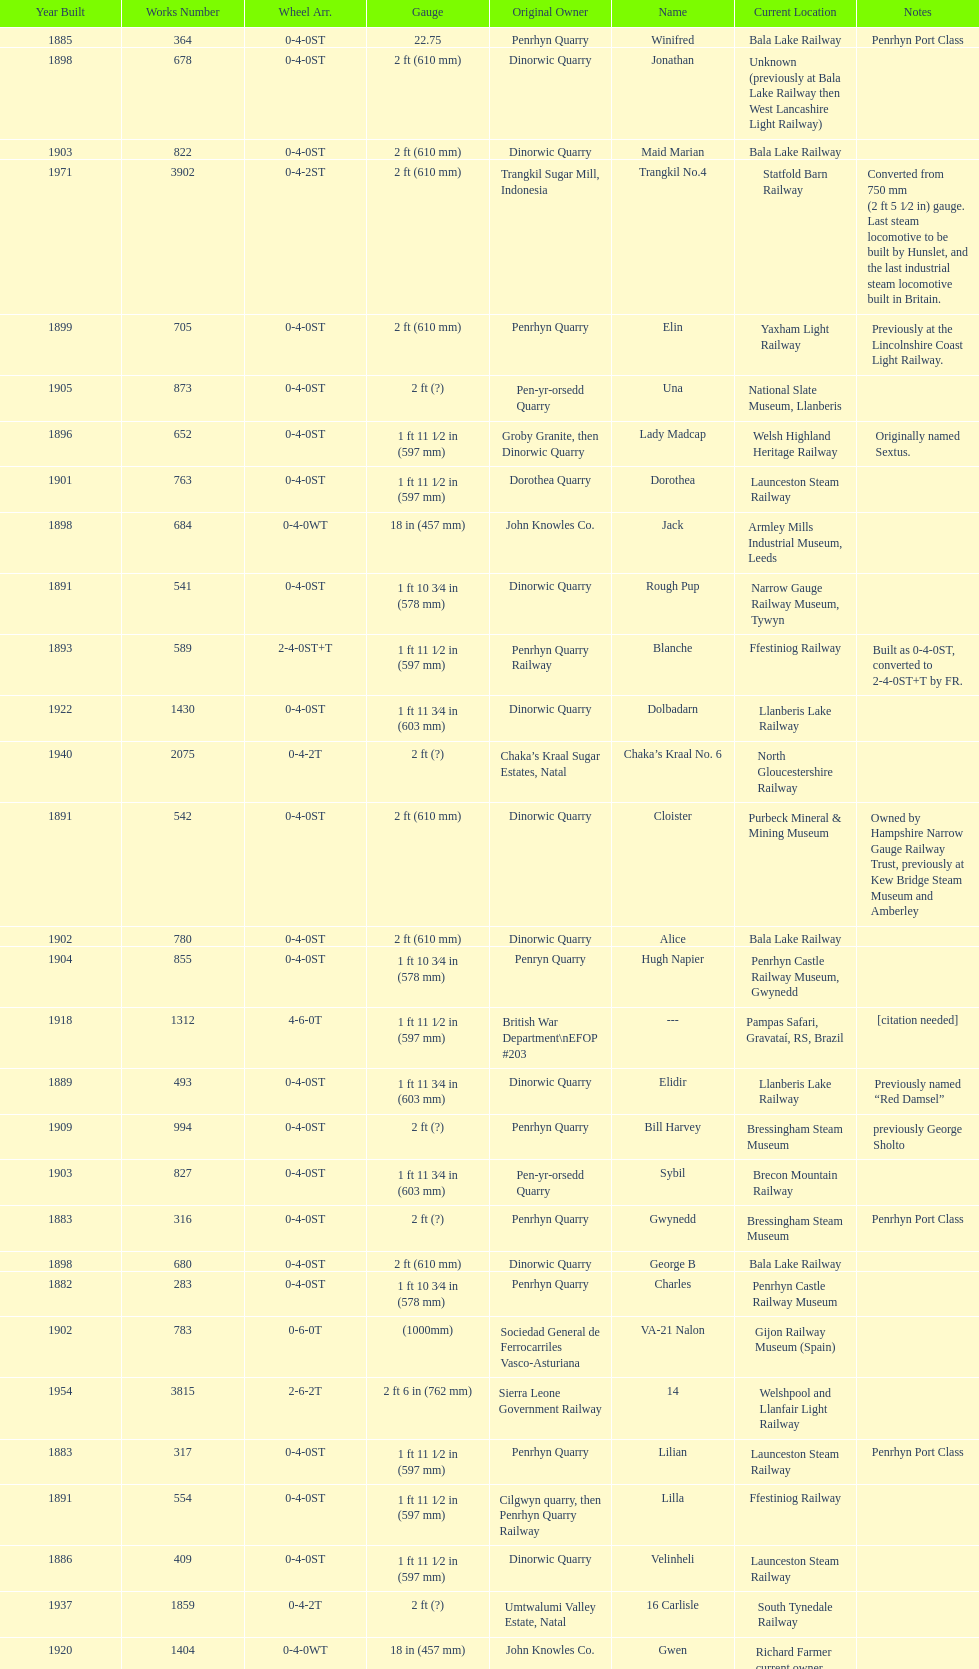Could you parse the entire table? {'header': ['Year Built', 'Works Number', 'Wheel Arr.', 'Gauge', 'Original Owner', 'Name', 'Current Location', 'Notes'], 'rows': [['1885', '364', '0-4-0ST', '22.75', 'Penrhyn Quarry', 'Winifred', 'Bala Lake Railway', 'Penrhyn Port Class'], ['1898', '678', '0-4-0ST', '2\xa0ft (610\xa0mm)', 'Dinorwic Quarry', 'Jonathan', 'Unknown (previously at Bala Lake Railway then West Lancashire Light Railway)', ''], ['1903', '822', '0-4-0ST', '2\xa0ft (610\xa0mm)', 'Dinorwic Quarry', 'Maid Marian', 'Bala Lake Railway', ''], ['1971', '3902', '0-4-2ST', '2\xa0ft (610\xa0mm)', 'Trangkil Sugar Mill, Indonesia', 'Trangkil No.4', 'Statfold Barn Railway', 'Converted from 750\xa0mm (2\xa0ft\xa05\xa01⁄2\xa0in) gauge. Last steam locomotive to be built by Hunslet, and the last industrial steam locomotive built in Britain.'], ['1899', '705', '0-4-0ST', '2\xa0ft (610\xa0mm)', 'Penrhyn Quarry', 'Elin', 'Yaxham Light Railway', 'Previously at the Lincolnshire Coast Light Railway.'], ['1905', '873', '0-4-0ST', '2\xa0ft (?)', 'Pen-yr-orsedd Quarry', 'Una', 'National Slate Museum, Llanberis', ''], ['1896', '652', '0-4-0ST', '1\xa0ft 11\xa01⁄2\xa0in (597\xa0mm)', 'Groby Granite, then Dinorwic Quarry', 'Lady Madcap', 'Welsh Highland Heritage Railway', 'Originally named Sextus.'], ['1901', '763', '0-4-0ST', '1\xa0ft 11\xa01⁄2\xa0in (597\xa0mm)', 'Dorothea Quarry', 'Dorothea', 'Launceston Steam Railway', ''], ['1898', '684', '0-4-0WT', '18\xa0in (457\xa0mm)', 'John Knowles Co.', 'Jack', 'Armley Mills Industrial Museum, Leeds', ''], ['1891', '541', '0-4-0ST', '1\xa0ft 10\xa03⁄4\xa0in (578\xa0mm)', 'Dinorwic Quarry', 'Rough Pup', 'Narrow Gauge Railway Museum, Tywyn', ''], ['1893', '589', '2-4-0ST+T', '1\xa0ft 11\xa01⁄2\xa0in (597\xa0mm)', 'Penrhyn Quarry Railway', 'Blanche', 'Ffestiniog Railway', 'Built as 0-4-0ST, converted to 2-4-0ST+T by FR.'], ['1922', '1430', '0-4-0ST', '1\xa0ft 11\xa03⁄4\xa0in (603\xa0mm)', 'Dinorwic Quarry', 'Dolbadarn', 'Llanberis Lake Railway', ''], ['1940', '2075', '0-4-2T', '2\xa0ft (?)', 'Chaka’s Kraal Sugar Estates, Natal', 'Chaka’s Kraal No. 6', 'North Gloucestershire Railway', ''], ['1891', '542', '0-4-0ST', '2\xa0ft (610\xa0mm)', 'Dinorwic Quarry', 'Cloister', 'Purbeck Mineral & Mining Museum', 'Owned by Hampshire Narrow Gauge Railway Trust, previously at Kew Bridge Steam Museum and Amberley'], ['1902', '780', '0-4-0ST', '2\xa0ft (610\xa0mm)', 'Dinorwic Quarry', 'Alice', 'Bala Lake Railway', ''], ['1904', '855', '0-4-0ST', '1\xa0ft 10\xa03⁄4\xa0in (578\xa0mm)', 'Penryn Quarry', 'Hugh Napier', 'Penrhyn Castle Railway Museum, Gwynedd', ''], ['1918', '1312', '4-6-0T', '1\xa0ft\xa011\xa01⁄2\xa0in (597\xa0mm)', 'British War Department\\nEFOP #203', '---', 'Pampas Safari, Gravataí, RS, Brazil', '[citation needed]'], ['1889', '493', '0-4-0ST', '1\xa0ft 11\xa03⁄4\xa0in (603\xa0mm)', 'Dinorwic Quarry', 'Elidir', 'Llanberis Lake Railway', 'Previously named “Red Damsel”'], ['1909', '994', '0-4-0ST', '2\xa0ft (?)', 'Penrhyn Quarry', 'Bill Harvey', 'Bressingham Steam Museum', 'previously George Sholto'], ['1903', '827', '0-4-0ST', '1\xa0ft 11\xa03⁄4\xa0in (603\xa0mm)', 'Pen-yr-orsedd Quarry', 'Sybil', 'Brecon Mountain Railway', ''], ['1883', '316', '0-4-0ST', '2\xa0ft (?)', 'Penrhyn Quarry', 'Gwynedd', 'Bressingham Steam Museum', 'Penrhyn Port Class'], ['1898', '680', '0-4-0ST', '2\xa0ft (610\xa0mm)', 'Dinorwic Quarry', 'George B', 'Bala Lake Railway', ''], ['1882', '283', '0-4-0ST', '1\xa0ft 10\xa03⁄4\xa0in (578\xa0mm)', 'Penrhyn Quarry', 'Charles', 'Penrhyn Castle Railway Museum', ''], ['1902', '783', '0-6-0T', '(1000mm)', 'Sociedad General de Ferrocarriles Vasco-Asturiana', 'VA-21 Nalon', 'Gijon Railway Museum (Spain)', ''], ['1954', '3815', '2-6-2T', '2\xa0ft 6\xa0in (762\xa0mm)', 'Sierra Leone Government Railway', '14', 'Welshpool and Llanfair Light Railway', ''], ['1883', '317', '0-4-0ST', '1\xa0ft 11\xa01⁄2\xa0in (597\xa0mm)', 'Penrhyn Quarry', 'Lilian', 'Launceston Steam Railway', 'Penrhyn Port Class'], ['1891', '554', '0-4-0ST', '1\xa0ft 11\xa01⁄2\xa0in (597\xa0mm)', 'Cilgwyn quarry, then Penrhyn Quarry Railway', 'Lilla', 'Ffestiniog Railway', ''], ['1886', '409', '0-4-0ST', '1\xa0ft 11\xa01⁄2\xa0in (597\xa0mm)', 'Dinorwic Quarry', 'Velinheli', 'Launceston Steam Railway', ''], ['1937', '1859', '0-4-2T', '2\xa0ft (?)', 'Umtwalumi Valley Estate, Natal', '16 Carlisle', 'South Tynedale Railway', ''], ['1920', '1404', '0-4-0WT', '18\xa0in (457\xa0mm)', 'John Knowles Co.', 'Gwen', 'Richard Farmer current owner, Northridge, California, USA', ''], ['1906', '920', '0-4-0ST', '2\xa0ft (?)', 'Penrhyn Quarry', 'Pamela', 'Old Kiln Light Railway', ''], ['1922', '1429', '0-4-0ST', '2\xa0ft (610\xa0mm)', 'Dinorwic', 'Lady Joan', 'Bredgar and Wormshill Light Railway', ''], ['1899', '707', '0-4-0ST', '1\xa0ft 11\xa01⁄2\xa0in (597\xa0mm)', 'Pen-yr-orsedd Quarry', 'Britomart', 'Ffestiniog Railway', ''], ['1898', '679', '0-4-0ST', '1\xa0ft 11\xa01⁄2\xa0in (597\xa0mm)', 'Dinorwic Quarry', 'Covercoat', 'Launceston Steam Railway', ''], ['1895', '638', '0-4-0ST', '2\xa0ft (610\xa0mm)', 'Dinorwic', 'Jerry M', 'Hollycombe Steam Collection', ''], ['1890', '518', '2-2-0T', '(1000mm)', 'S.V.T. 8', 'Tortosa-La Cava1', 'Tortosa (catalonia, Spain)', ''], ['1903', '823', '0-4-0ST', '2\xa0ft (?)', 'Dinorwic Quarry', 'Irish Mail', 'West Lancashire Light Railway', ''], ['1906', '901', '2-6-2T', '1\xa0ft 11\xa01⁄2\xa0in (597\xa0mm)', 'North Wales Narrow Gauge Railways', 'Russell', 'Welsh Highland Heritage Railway', ''], ['1893', '590', '2-4-0ST+T', '1\xa0ft 11\xa01⁄2\xa0in (597\xa0mm)', 'Penrhyn Quarry Railway', 'Linda', 'Ffestiniog Railway', 'Built as 0-4-0ST, converted to 2-4-0ST+T by FR.'], ['1902', '779', '0-4-0ST', '2\xa0ft (610\xa0mm)', 'Dinorwic Quarry', 'Holy War', 'Bala Lake Railway', ''], ['1894', '605', '0-4-0ST', '1\xa0ft 11\xa03⁄4\xa0in (603\xa0mm)', 'Penrhyn Quarry', 'Margaret', 'Vale of Rheidol Railway', 'Under restoration.[citation needed]'], ['1918\\nor\\n1921?', '1313', '0-6-2T', '3\xa0ft\xa03\xa03⁄8\xa0in (1,000\xa0mm)', 'British War Department\\nUsina Leão Utinga #1\\nUsina Laginha #1', '---', 'Usina Laginha, União dos Palmares, AL, Brazil', '[citation needed]'], ['1904', '894', '0-4-0ST', '1\xa0ft 11\xa03⁄4\xa0in (603\xa0mm)', 'Dinorwic Quarry', 'Thomas Bach', 'Llanberis Lake Railway', 'Originally named “Wild Aster”'], ['1894', '606', '0-4-0ST', '2\xa0ft (?)', 'Penrhyn Quarry', 'Alan George', 'Teifi Valley Railway', '']]} After 1940, how many steam locomotives were built? 2. 